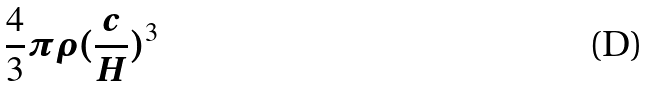Convert formula to latex. <formula><loc_0><loc_0><loc_500><loc_500>\frac { 4 } { 3 } \pi \rho ( \frac { c } { H } ) ^ { 3 }</formula> 